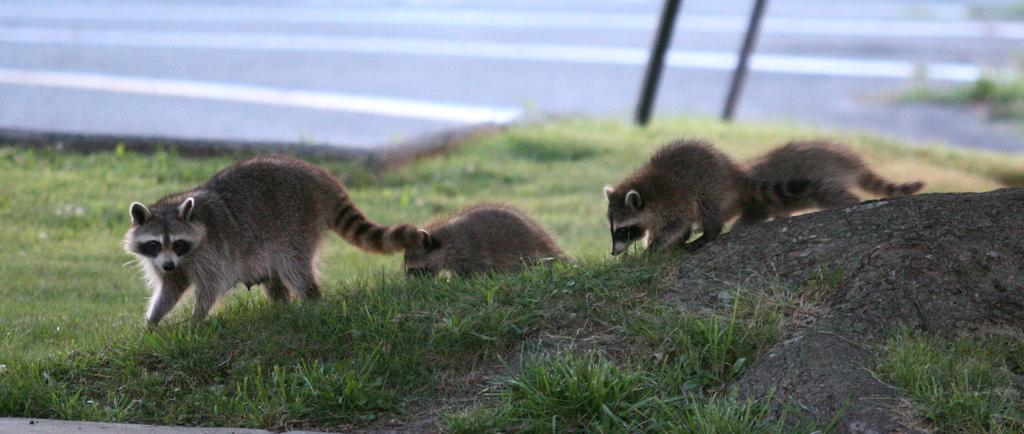What animals are present in the image? There are raccoons in the image. What are the raccoons doing in the image? The raccoons are working on the ground. Where are the raccoons located in the image? The raccoons are located towards the left side of the image. What type of vegetation can be seen in the background of the image? There is grass visible in the background of the image. What object can be seen on the right side of the image? There is a rock on the right side of the image. What type of polish is the father using to design the rock in the image? There is no father or polish present in the image, and the rock is not being designed. 